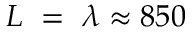<formula> <loc_0><loc_0><loc_500><loc_500>L = \lambda \approx 8 5 0</formula> 